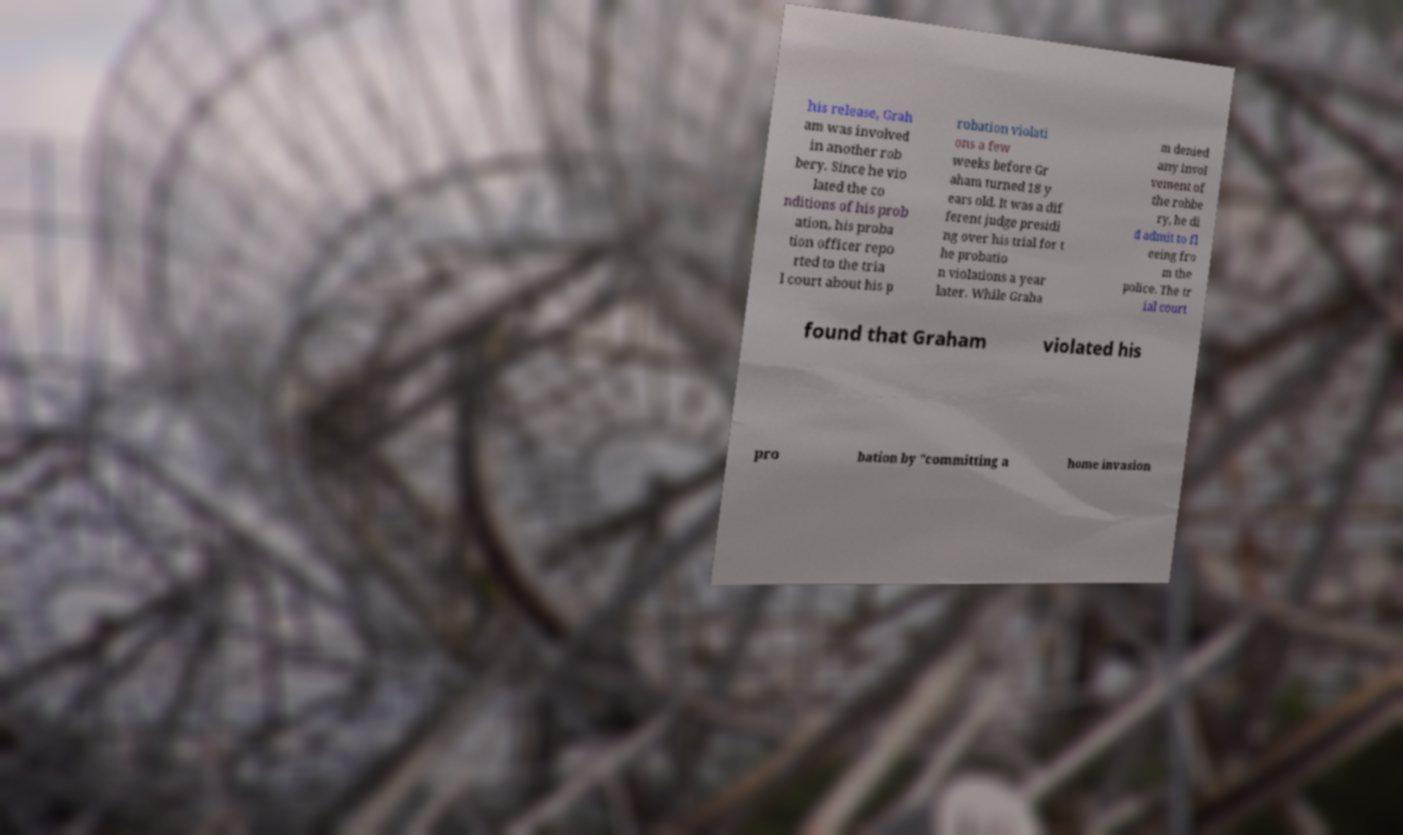Could you assist in decoding the text presented in this image and type it out clearly? his release, Grah am was involved in another rob bery. Since he vio lated the co nditions of his prob ation, his proba tion officer repo rted to the tria l court about his p robation violati ons a few weeks before Gr aham turned 18 y ears old. It was a dif ferent judge presidi ng over his trial for t he probatio n violations a year later. While Graha m denied any invol vement of the robbe ry, he di d admit to fl eeing fro m the police. The tr ial court found that Graham violated his pro bation by "committing a home invasion 